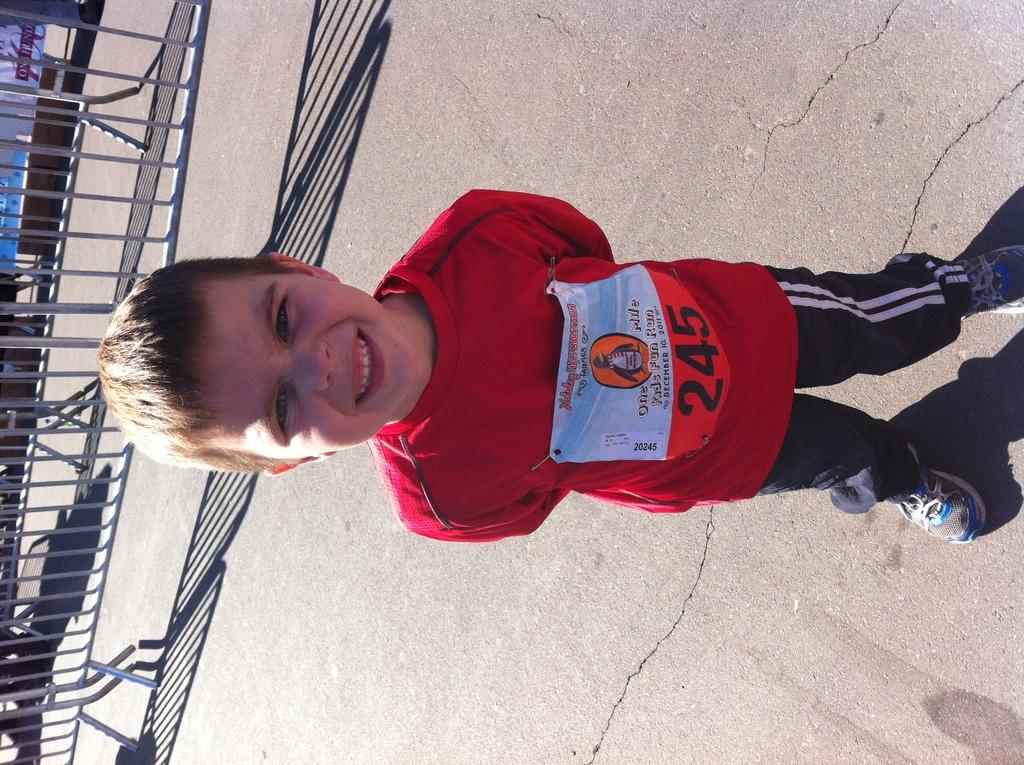What is the main subject of the image? The main subject of the image is a kid standing. Where is the kid standing? The kid is standing on the floor. What can be seen in the background of the image? There is a fence in the background of the image. What is the kid wearing? The kid is wearing a red color t-shirt. Can you describe any additional details about the kid's clothing? Yes, there is a badge attached to the kid's t-shirt. What type of boats can be seen in the harbor in the image? There is no harbor or boats present in the image; it features a kid standing with a fence in the background. What color is the sky in the image? The provided facts do not mention the color of the sky, so it cannot be determined from the image. 